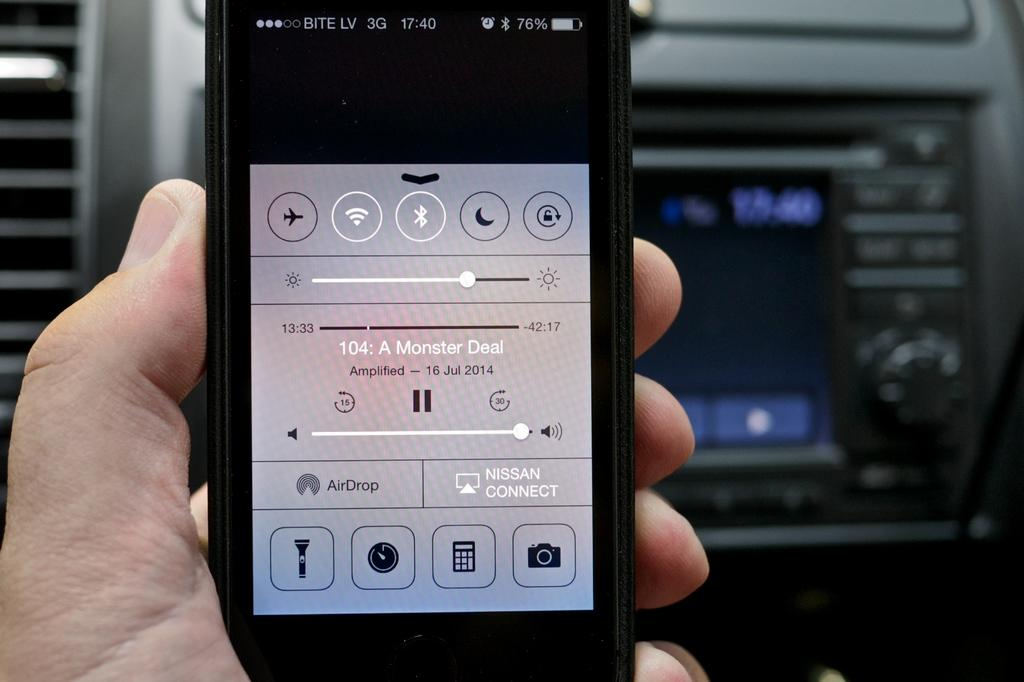<image>
Share a concise interpretation of the image provided. a phone with the word monster in the middle 